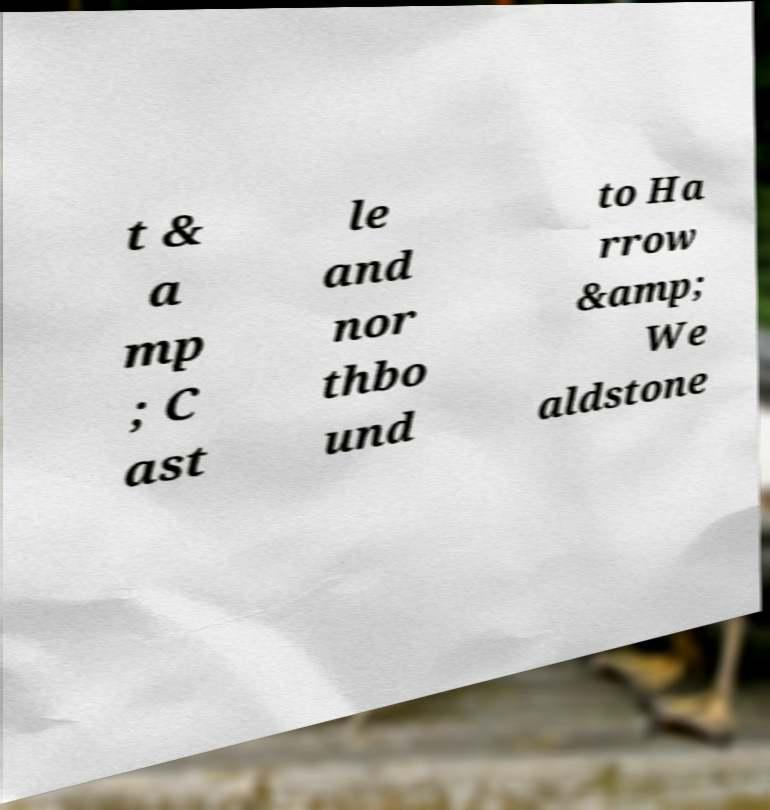There's text embedded in this image that I need extracted. Can you transcribe it verbatim? t & a mp ; C ast le and nor thbo und to Ha rrow &amp; We aldstone 